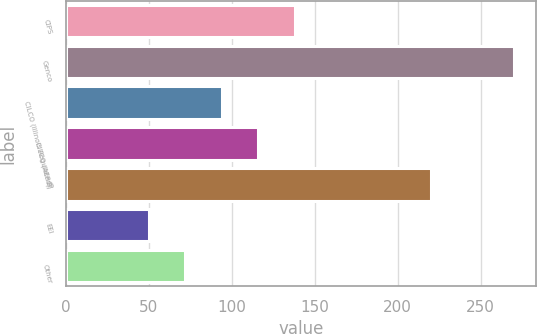Convert chart. <chart><loc_0><loc_0><loc_500><loc_500><bar_chart><fcel>CIPS<fcel>Genco<fcel>CILCO (Illinois Regulated)<fcel>CILCO (AERG)<fcel>IP<fcel>EEI<fcel>Other<nl><fcel>138<fcel>270<fcel>94<fcel>116<fcel>220<fcel>50<fcel>72<nl></chart> 